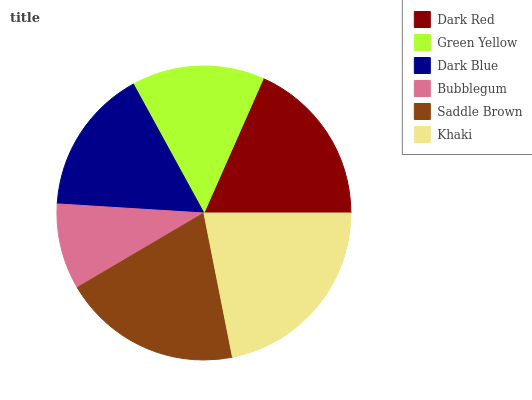Is Bubblegum the minimum?
Answer yes or no. Yes. Is Khaki the maximum?
Answer yes or no. Yes. Is Green Yellow the minimum?
Answer yes or no. No. Is Green Yellow the maximum?
Answer yes or no. No. Is Dark Red greater than Green Yellow?
Answer yes or no. Yes. Is Green Yellow less than Dark Red?
Answer yes or no. Yes. Is Green Yellow greater than Dark Red?
Answer yes or no. No. Is Dark Red less than Green Yellow?
Answer yes or no. No. Is Dark Red the high median?
Answer yes or no. Yes. Is Dark Blue the low median?
Answer yes or no. Yes. Is Khaki the high median?
Answer yes or no. No. Is Khaki the low median?
Answer yes or no. No. 